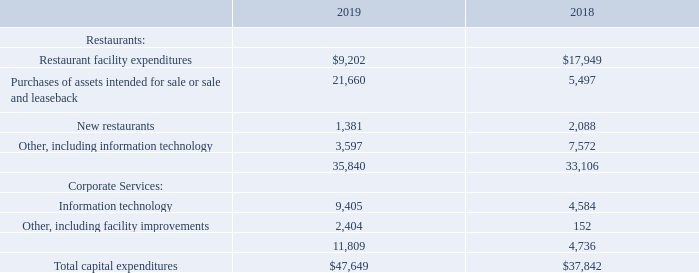Investing Activities. Cash flows (used in) provided by investing activities changed from a source of$65.7 million in 2018 to a use of $13.8 million in 2019. This change of$79.5 million primarily resulted from a decrease of$62.9 million in cash proceeds from the sale of company-operated restaurants, including repayments of notes issued in connection with 2018 refranchising transactions, and an increase of $9.8 million in capital expenditures.
Capital Expenditures — The composition of capital expenditures in each fiscal year is summarized in the table below (in thousands):
Our capital expenditure program includes, among other things, restaurant remodeling, information technology enhancements, and investments in new locations and equipment. In 2019, capital expenditures increased by $9.8 million primarily due to an increase of $16.2 million in purchases of assets intended for sale or sale and leaseback, partially offset by a $8.7 million decrease in restaurant capital maintenance and facility improvement spending mainly from a decrease in the average number of company-operated restaurants compared to the prior year. The increase in purchases of assets intended for sale or sale and leaseback was primarily due to the Company’s purchase of a commercial property in Los Angeles, California, on which an existing company restaurant and another retail tenant are located. The purchase price was $17.3 million, and we currently intend to sell the entire property and lease back the parcel on which our company operated restaurant is located within the next 12 months.
What is the total capital expenditure in 2019?
Answer scale should be: thousand. $47,649. What is the increase in capital expenditure from 2018 to 2019? $9.8 million. Why was there an increase in purchases of assets intended for sale or sale and leaseback? Purchase of a commercial property in los angeles, california. What is the difference in restaurant facility expenditures between 2018 and 2019?
Answer scale should be: thousand. $17,949 - $9,202 
Answer: 8747. What is the average capital expenditure spent on information technology for 2018 and 2019?
Answer scale should be: thousand. ($9,405+$4,584)/2 
Answer: 6994.5. What is the difference in total capital expenditure for restaurants and total capital expenditure for corporate services in 2018?
Answer scale should be: thousand. $33,106-$4,736
Answer: 28370. 